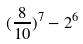Convert formula to latex. <formula><loc_0><loc_0><loc_500><loc_500>( \frac { 8 } { 1 0 } ) ^ { 7 } - 2 ^ { 6 }</formula> 